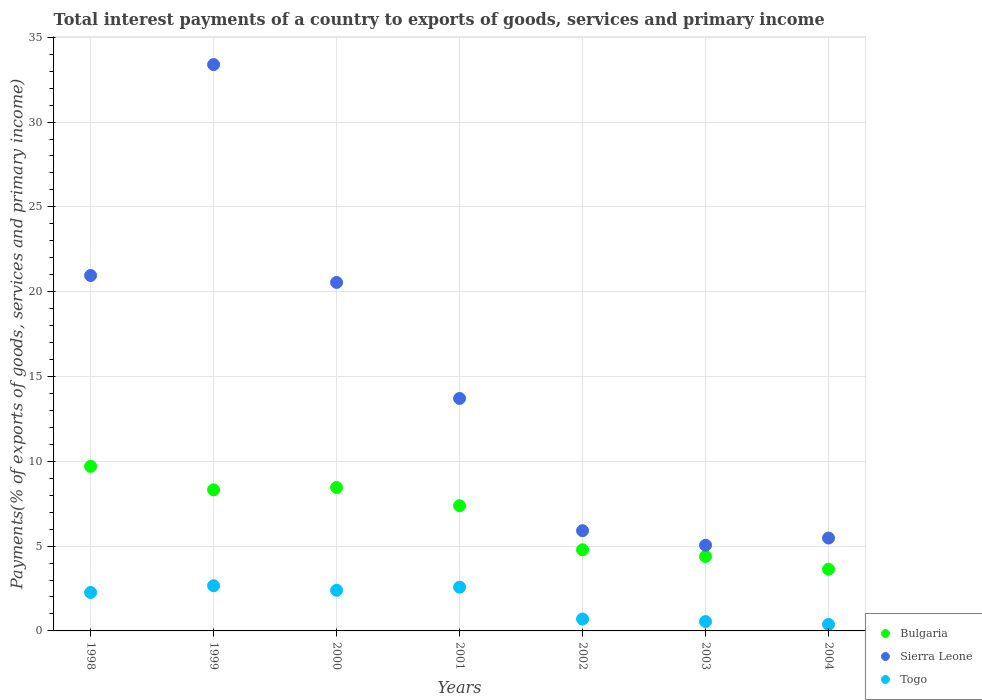What is the total interest payments in Sierra Leone in 2004?
Offer a terse response. 5.48. Across all years, what is the maximum total interest payments in Togo?
Provide a succinct answer. 2.66. Across all years, what is the minimum total interest payments in Sierra Leone?
Give a very brief answer. 5.05. In which year was the total interest payments in Sierra Leone maximum?
Provide a short and direct response. 1999. In which year was the total interest payments in Sierra Leone minimum?
Ensure brevity in your answer.  2003. What is the total total interest payments in Sierra Leone in the graph?
Your answer should be compact. 105.03. What is the difference between the total interest payments in Togo in 2003 and that in 2004?
Make the answer very short. 0.17. What is the difference between the total interest payments in Bulgaria in 2004 and the total interest payments in Togo in 2000?
Offer a terse response. 1.24. What is the average total interest payments in Bulgaria per year?
Ensure brevity in your answer.  6.67. In the year 1999, what is the difference between the total interest payments in Togo and total interest payments in Bulgaria?
Provide a succinct answer. -5.65. What is the ratio of the total interest payments in Togo in 1998 to that in 1999?
Keep it short and to the point. 0.85. Is the total interest payments in Sierra Leone in 2003 less than that in 2004?
Give a very brief answer. Yes. What is the difference between the highest and the second highest total interest payments in Togo?
Ensure brevity in your answer.  0.08. What is the difference between the highest and the lowest total interest payments in Bulgaria?
Your answer should be very brief. 6.07. In how many years, is the total interest payments in Togo greater than the average total interest payments in Togo taken over all years?
Keep it short and to the point. 4. Is the sum of the total interest payments in Togo in 2001 and 2002 greater than the maximum total interest payments in Bulgaria across all years?
Offer a very short reply. No. Does the total interest payments in Sierra Leone monotonically increase over the years?
Your response must be concise. No. Is the total interest payments in Sierra Leone strictly greater than the total interest payments in Bulgaria over the years?
Keep it short and to the point. Yes. How many years are there in the graph?
Provide a succinct answer. 7. What is the difference between two consecutive major ticks on the Y-axis?
Your response must be concise. 5. Are the values on the major ticks of Y-axis written in scientific E-notation?
Give a very brief answer. No. Does the graph contain grids?
Your answer should be compact. Yes. Where does the legend appear in the graph?
Make the answer very short. Bottom right. How are the legend labels stacked?
Ensure brevity in your answer.  Vertical. What is the title of the graph?
Offer a terse response. Total interest payments of a country to exports of goods, services and primary income. Does "Sudan" appear as one of the legend labels in the graph?
Your response must be concise. No. What is the label or title of the X-axis?
Provide a short and direct response. Years. What is the label or title of the Y-axis?
Give a very brief answer. Payments(% of exports of goods, services and primary income). What is the Payments(% of exports of goods, services and primary income) of Bulgaria in 1998?
Make the answer very short. 9.7. What is the Payments(% of exports of goods, services and primary income) of Sierra Leone in 1998?
Provide a short and direct response. 20.95. What is the Payments(% of exports of goods, services and primary income) of Togo in 1998?
Provide a short and direct response. 2.27. What is the Payments(% of exports of goods, services and primary income) in Bulgaria in 1999?
Keep it short and to the point. 8.32. What is the Payments(% of exports of goods, services and primary income) of Sierra Leone in 1999?
Provide a short and direct response. 33.39. What is the Payments(% of exports of goods, services and primary income) of Togo in 1999?
Offer a very short reply. 2.66. What is the Payments(% of exports of goods, services and primary income) in Bulgaria in 2000?
Provide a short and direct response. 8.45. What is the Payments(% of exports of goods, services and primary income) of Sierra Leone in 2000?
Your response must be concise. 20.55. What is the Payments(% of exports of goods, services and primary income) in Togo in 2000?
Offer a very short reply. 2.4. What is the Payments(% of exports of goods, services and primary income) of Bulgaria in 2001?
Your answer should be compact. 7.38. What is the Payments(% of exports of goods, services and primary income) of Sierra Leone in 2001?
Provide a short and direct response. 13.71. What is the Payments(% of exports of goods, services and primary income) of Togo in 2001?
Ensure brevity in your answer.  2.58. What is the Payments(% of exports of goods, services and primary income) of Bulgaria in 2002?
Your answer should be very brief. 4.78. What is the Payments(% of exports of goods, services and primary income) in Sierra Leone in 2002?
Your answer should be compact. 5.91. What is the Payments(% of exports of goods, services and primary income) of Togo in 2002?
Offer a very short reply. 0.7. What is the Payments(% of exports of goods, services and primary income) of Bulgaria in 2003?
Ensure brevity in your answer.  4.39. What is the Payments(% of exports of goods, services and primary income) in Sierra Leone in 2003?
Make the answer very short. 5.05. What is the Payments(% of exports of goods, services and primary income) in Togo in 2003?
Ensure brevity in your answer.  0.55. What is the Payments(% of exports of goods, services and primary income) in Bulgaria in 2004?
Keep it short and to the point. 3.64. What is the Payments(% of exports of goods, services and primary income) in Sierra Leone in 2004?
Make the answer very short. 5.48. What is the Payments(% of exports of goods, services and primary income) in Togo in 2004?
Your response must be concise. 0.38. Across all years, what is the maximum Payments(% of exports of goods, services and primary income) in Bulgaria?
Offer a terse response. 9.7. Across all years, what is the maximum Payments(% of exports of goods, services and primary income) in Sierra Leone?
Provide a short and direct response. 33.39. Across all years, what is the maximum Payments(% of exports of goods, services and primary income) in Togo?
Offer a terse response. 2.66. Across all years, what is the minimum Payments(% of exports of goods, services and primary income) of Bulgaria?
Your answer should be compact. 3.64. Across all years, what is the minimum Payments(% of exports of goods, services and primary income) of Sierra Leone?
Make the answer very short. 5.05. Across all years, what is the minimum Payments(% of exports of goods, services and primary income) in Togo?
Your answer should be very brief. 0.38. What is the total Payments(% of exports of goods, services and primary income) of Bulgaria in the graph?
Offer a terse response. 46.66. What is the total Payments(% of exports of goods, services and primary income) of Sierra Leone in the graph?
Your answer should be very brief. 105.03. What is the total Payments(% of exports of goods, services and primary income) in Togo in the graph?
Provide a succinct answer. 11.54. What is the difference between the Payments(% of exports of goods, services and primary income) of Bulgaria in 1998 and that in 1999?
Provide a short and direct response. 1.38. What is the difference between the Payments(% of exports of goods, services and primary income) of Sierra Leone in 1998 and that in 1999?
Give a very brief answer. -12.44. What is the difference between the Payments(% of exports of goods, services and primary income) in Togo in 1998 and that in 1999?
Offer a very short reply. -0.4. What is the difference between the Payments(% of exports of goods, services and primary income) of Bulgaria in 1998 and that in 2000?
Offer a terse response. 1.25. What is the difference between the Payments(% of exports of goods, services and primary income) of Sierra Leone in 1998 and that in 2000?
Ensure brevity in your answer.  0.41. What is the difference between the Payments(% of exports of goods, services and primary income) in Togo in 1998 and that in 2000?
Ensure brevity in your answer.  -0.13. What is the difference between the Payments(% of exports of goods, services and primary income) of Bulgaria in 1998 and that in 2001?
Your answer should be very brief. 2.32. What is the difference between the Payments(% of exports of goods, services and primary income) of Sierra Leone in 1998 and that in 2001?
Your answer should be compact. 7.25. What is the difference between the Payments(% of exports of goods, services and primary income) of Togo in 1998 and that in 2001?
Provide a short and direct response. -0.31. What is the difference between the Payments(% of exports of goods, services and primary income) of Bulgaria in 1998 and that in 2002?
Your answer should be very brief. 4.92. What is the difference between the Payments(% of exports of goods, services and primary income) in Sierra Leone in 1998 and that in 2002?
Give a very brief answer. 15.05. What is the difference between the Payments(% of exports of goods, services and primary income) in Togo in 1998 and that in 2002?
Your answer should be very brief. 1.56. What is the difference between the Payments(% of exports of goods, services and primary income) of Bulgaria in 1998 and that in 2003?
Provide a short and direct response. 5.31. What is the difference between the Payments(% of exports of goods, services and primary income) in Sierra Leone in 1998 and that in 2003?
Your response must be concise. 15.9. What is the difference between the Payments(% of exports of goods, services and primary income) in Togo in 1998 and that in 2003?
Your answer should be very brief. 1.71. What is the difference between the Payments(% of exports of goods, services and primary income) of Bulgaria in 1998 and that in 2004?
Make the answer very short. 6.07. What is the difference between the Payments(% of exports of goods, services and primary income) of Sierra Leone in 1998 and that in 2004?
Your answer should be very brief. 15.48. What is the difference between the Payments(% of exports of goods, services and primary income) in Togo in 1998 and that in 2004?
Offer a very short reply. 1.88. What is the difference between the Payments(% of exports of goods, services and primary income) in Bulgaria in 1999 and that in 2000?
Provide a succinct answer. -0.14. What is the difference between the Payments(% of exports of goods, services and primary income) in Sierra Leone in 1999 and that in 2000?
Provide a short and direct response. 12.84. What is the difference between the Payments(% of exports of goods, services and primary income) in Togo in 1999 and that in 2000?
Offer a terse response. 0.27. What is the difference between the Payments(% of exports of goods, services and primary income) of Bulgaria in 1999 and that in 2001?
Keep it short and to the point. 0.94. What is the difference between the Payments(% of exports of goods, services and primary income) in Sierra Leone in 1999 and that in 2001?
Ensure brevity in your answer.  19.68. What is the difference between the Payments(% of exports of goods, services and primary income) of Togo in 1999 and that in 2001?
Provide a short and direct response. 0.08. What is the difference between the Payments(% of exports of goods, services and primary income) of Bulgaria in 1999 and that in 2002?
Provide a short and direct response. 3.53. What is the difference between the Payments(% of exports of goods, services and primary income) in Sierra Leone in 1999 and that in 2002?
Provide a short and direct response. 27.48. What is the difference between the Payments(% of exports of goods, services and primary income) of Togo in 1999 and that in 2002?
Give a very brief answer. 1.96. What is the difference between the Payments(% of exports of goods, services and primary income) of Bulgaria in 1999 and that in 2003?
Make the answer very short. 3.93. What is the difference between the Payments(% of exports of goods, services and primary income) of Sierra Leone in 1999 and that in 2003?
Your answer should be compact. 28.34. What is the difference between the Payments(% of exports of goods, services and primary income) in Togo in 1999 and that in 2003?
Your response must be concise. 2.11. What is the difference between the Payments(% of exports of goods, services and primary income) in Bulgaria in 1999 and that in 2004?
Your response must be concise. 4.68. What is the difference between the Payments(% of exports of goods, services and primary income) of Sierra Leone in 1999 and that in 2004?
Your answer should be compact. 27.91. What is the difference between the Payments(% of exports of goods, services and primary income) of Togo in 1999 and that in 2004?
Provide a succinct answer. 2.28. What is the difference between the Payments(% of exports of goods, services and primary income) of Bulgaria in 2000 and that in 2001?
Keep it short and to the point. 1.07. What is the difference between the Payments(% of exports of goods, services and primary income) in Sierra Leone in 2000 and that in 2001?
Keep it short and to the point. 6.84. What is the difference between the Payments(% of exports of goods, services and primary income) of Togo in 2000 and that in 2001?
Offer a terse response. -0.18. What is the difference between the Payments(% of exports of goods, services and primary income) in Bulgaria in 2000 and that in 2002?
Ensure brevity in your answer.  3.67. What is the difference between the Payments(% of exports of goods, services and primary income) in Sierra Leone in 2000 and that in 2002?
Your answer should be compact. 14.64. What is the difference between the Payments(% of exports of goods, services and primary income) of Togo in 2000 and that in 2002?
Your response must be concise. 1.7. What is the difference between the Payments(% of exports of goods, services and primary income) of Bulgaria in 2000 and that in 2003?
Your answer should be very brief. 4.07. What is the difference between the Payments(% of exports of goods, services and primary income) in Sierra Leone in 2000 and that in 2003?
Keep it short and to the point. 15.49. What is the difference between the Payments(% of exports of goods, services and primary income) of Togo in 2000 and that in 2003?
Keep it short and to the point. 1.85. What is the difference between the Payments(% of exports of goods, services and primary income) of Bulgaria in 2000 and that in 2004?
Offer a terse response. 4.82. What is the difference between the Payments(% of exports of goods, services and primary income) of Sierra Leone in 2000 and that in 2004?
Make the answer very short. 15.07. What is the difference between the Payments(% of exports of goods, services and primary income) of Togo in 2000 and that in 2004?
Make the answer very short. 2.01. What is the difference between the Payments(% of exports of goods, services and primary income) in Bulgaria in 2001 and that in 2002?
Provide a short and direct response. 2.6. What is the difference between the Payments(% of exports of goods, services and primary income) in Sierra Leone in 2001 and that in 2002?
Your answer should be compact. 7.8. What is the difference between the Payments(% of exports of goods, services and primary income) in Togo in 2001 and that in 2002?
Offer a terse response. 1.88. What is the difference between the Payments(% of exports of goods, services and primary income) of Bulgaria in 2001 and that in 2003?
Ensure brevity in your answer.  2.99. What is the difference between the Payments(% of exports of goods, services and primary income) of Sierra Leone in 2001 and that in 2003?
Provide a short and direct response. 8.65. What is the difference between the Payments(% of exports of goods, services and primary income) in Togo in 2001 and that in 2003?
Your response must be concise. 2.03. What is the difference between the Payments(% of exports of goods, services and primary income) of Bulgaria in 2001 and that in 2004?
Provide a succinct answer. 3.74. What is the difference between the Payments(% of exports of goods, services and primary income) in Sierra Leone in 2001 and that in 2004?
Your answer should be compact. 8.23. What is the difference between the Payments(% of exports of goods, services and primary income) in Togo in 2001 and that in 2004?
Your answer should be compact. 2.19. What is the difference between the Payments(% of exports of goods, services and primary income) of Bulgaria in 2002 and that in 2003?
Make the answer very short. 0.39. What is the difference between the Payments(% of exports of goods, services and primary income) in Sierra Leone in 2002 and that in 2003?
Give a very brief answer. 0.86. What is the difference between the Payments(% of exports of goods, services and primary income) of Togo in 2002 and that in 2003?
Give a very brief answer. 0.15. What is the difference between the Payments(% of exports of goods, services and primary income) of Bulgaria in 2002 and that in 2004?
Provide a short and direct response. 1.15. What is the difference between the Payments(% of exports of goods, services and primary income) in Sierra Leone in 2002 and that in 2004?
Your answer should be compact. 0.43. What is the difference between the Payments(% of exports of goods, services and primary income) of Togo in 2002 and that in 2004?
Give a very brief answer. 0.32. What is the difference between the Payments(% of exports of goods, services and primary income) in Bulgaria in 2003 and that in 2004?
Your response must be concise. 0.75. What is the difference between the Payments(% of exports of goods, services and primary income) of Sierra Leone in 2003 and that in 2004?
Your response must be concise. -0.42. What is the difference between the Payments(% of exports of goods, services and primary income) in Togo in 2003 and that in 2004?
Provide a short and direct response. 0.17. What is the difference between the Payments(% of exports of goods, services and primary income) of Bulgaria in 1998 and the Payments(% of exports of goods, services and primary income) of Sierra Leone in 1999?
Your answer should be compact. -23.69. What is the difference between the Payments(% of exports of goods, services and primary income) of Bulgaria in 1998 and the Payments(% of exports of goods, services and primary income) of Togo in 1999?
Offer a terse response. 7.04. What is the difference between the Payments(% of exports of goods, services and primary income) in Sierra Leone in 1998 and the Payments(% of exports of goods, services and primary income) in Togo in 1999?
Your response must be concise. 18.29. What is the difference between the Payments(% of exports of goods, services and primary income) in Bulgaria in 1998 and the Payments(% of exports of goods, services and primary income) in Sierra Leone in 2000?
Offer a terse response. -10.84. What is the difference between the Payments(% of exports of goods, services and primary income) of Bulgaria in 1998 and the Payments(% of exports of goods, services and primary income) of Togo in 2000?
Your response must be concise. 7.31. What is the difference between the Payments(% of exports of goods, services and primary income) of Sierra Leone in 1998 and the Payments(% of exports of goods, services and primary income) of Togo in 2000?
Your response must be concise. 18.56. What is the difference between the Payments(% of exports of goods, services and primary income) in Bulgaria in 1998 and the Payments(% of exports of goods, services and primary income) in Sierra Leone in 2001?
Keep it short and to the point. -4. What is the difference between the Payments(% of exports of goods, services and primary income) in Bulgaria in 1998 and the Payments(% of exports of goods, services and primary income) in Togo in 2001?
Your answer should be compact. 7.12. What is the difference between the Payments(% of exports of goods, services and primary income) of Sierra Leone in 1998 and the Payments(% of exports of goods, services and primary income) of Togo in 2001?
Your answer should be very brief. 18.37. What is the difference between the Payments(% of exports of goods, services and primary income) in Bulgaria in 1998 and the Payments(% of exports of goods, services and primary income) in Sierra Leone in 2002?
Ensure brevity in your answer.  3.79. What is the difference between the Payments(% of exports of goods, services and primary income) in Bulgaria in 1998 and the Payments(% of exports of goods, services and primary income) in Togo in 2002?
Your response must be concise. 9. What is the difference between the Payments(% of exports of goods, services and primary income) in Sierra Leone in 1998 and the Payments(% of exports of goods, services and primary income) in Togo in 2002?
Offer a terse response. 20.25. What is the difference between the Payments(% of exports of goods, services and primary income) of Bulgaria in 1998 and the Payments(% of exports of goods, services and primary income) of Sierra Leone in 2003?
Ensure brevity in your answer.  4.65. What is the difference between the Payments(% of exports of goods, services and primary income) in Bulgaria in 1998 and the Payments(% of exports of goods, services and primary income) in Togo in 2003?
Provide a short and direct response. 9.15. What is the difference between the Payments(% of exports of goods, services and primary income) in Sierra Leone in 1998 and the Payments(% of exports of goods, services and primary income) in Togo in 2003?
Provide a succinct answer. 20.4. What is the difference between the Payments(% of exports of goods, services and primary income) in Bulgaria in 1998 and the Payments(% of exports of goods, services and primary income) in Sierra Leone in 2004?
Make the answer very short. 4.23. What is the difference between the Payments(% of exports of goods, services and primary income) in Bulgaria in 1998 and the Payments(% of exports of goods, services and primary income) in Togo in 2004?
Keep it short and to the point. 9.32. What is the difference between the Payments(% of exports of goods, services and primary income) in Sierra Leone in 1998 and the Payments(% of exports of goods, services and primary income) in Togo in 2004?
Your answer should be compact. 20.57. What is the difference between the Payments(% of exports of goods, services and primary income) of Bulgaria in 1999 and the Payments(% of exports of goods, services and primary income) of Sierra Leone in 2000?
Offer a very short reply. -12.23. What is the difference between the Payments(% of exports of goods, services and primary income) in Bulgaria in 1999 and the Payments(% of exports of goods, services and primary income) in Togo in 2000?
Ensure brevity in your answer.  5.92. What is the difference between the Payments(% of exports of goods, services and primary income) of Sierra Leone in 1999 and the Payments(% of exports of goods, services and primary income) of Togo in 2000?
Keep it short and to the point. 30.99. What is the difference between the Payments(% of exports of goods, services and primary income) in Bulgaria in 1999 and the Payments(% of exports of goods, services and primary income) in Sierra Leone in 2001?
Keep it short and to the point. -5.39. What is the difference between the Payments(% of exports of goods, services and primary income) in Bulgaria in 1999 and the Payments(% of exports of goods, services and primary income) in Togo in 2001?
Offer a terse response. 5.74. What is the difference between the Payments(% of exports of goods, services and primary income) in Sierra Leone in 1999 and the Payments(% of exports of goods, services and primary income) in Togo in 2001?
Provide a short and direct response. 30.81. What is the difference between the Payments(% of exports of goods, services and primary income) in Bulgaria in 1999 and the Payments(% of exports of goods, services and primary income) in Sierra Leone in 2002?
Your answer should be compact. 2.41. What is the difference between the Payments(% of exports of goods, services and primary income) of Bulgaria in 1999 and the Payments(% of exports of goods, services and primary income) of Togo in 2002?
Your answer should be compact. 7.62. What is the difference between the Payments(% of exports of goods, services and primary income) of Sierra Leone in 1999 and the Payments(% of exports of goods, services and primary income) of Togo in 2002?
Offer a terse response. 32.69. What is the difference between the Payments(% of exports of goods, services and primary income) of Bulgaria in 1999 and the Payments(% of exports of goods, services and primary income) of Sierra Leone in 2003?
Ensure brevity in your answer.  3.26. What is the difference between the Payments(% of exports of goods, services and primary income) in Bulgaria in 1999 and the Payments(% of exports of goods, services and primary income) in Togo in 2003?
Your answer should be compact. 7.77. What is the difference between the Payments(% of exports of goods, services and primary income) in Sierra Leone in 1999 and the Payments(% of exports of goods, services and primary income) in Togo in 2003?
Your answer should be compact. 32.84. What is the difference between the Payments(% of exports of goods, services and primary income) of Bulgaria in 1999 and the Payments(% of exports of goods, services and primary income) of Sierra Leone in 2004?
Your answer should be compact. 2.84. What is the difference between the Payments(% of exports of goods, services and primary income) in Bulgaria in 1999 and the Payments(% of exports of goods, services and primary income) in Togo in 2004?
Your answer should be very brief. 7.93. What is the difference between the Payments(% of exports of goods, services and primary income) in Sierra Leone in 1999 and the Payments(% of exports of goods, services and primary income) in Togo in 2004?
Your response must be concise. 33. What is the difference between the Payments(% of exports of goods, services and primary income) in Bulgaria in 2000 and the Payments(% of exports of goods, services and primary income) in Sierra Leone in 2001?
Keep it short and to the point. -5.25. What is the difference between the Payments(% of exports of goods, services and primary income) in Bulgaria in 2000 and the Payments(% of exports of goods, services and primary income) in Togo in 2001?
Your answer should be compact. 5.88. What is the difference between the Payments(% of exports of goods, services and primary income) of Sierra Leone in 2000 and the Payments(% of exports of goods, services and primary income) of Togo in 2001?
Give a very brief answer. 17.97. What is the difference between the Payments(% of exports of goods, services and primary income) of Bulgaria in 2000 and the Payments(% of exports of goods, services and primary income) of Sierra Leone in 2002?
Your answer should be compact. 2.55. What is the difference between the Payments(% of exports of goods, services and primary income) of Bulgaria in 2000 and the Payments(% of exports of goods, services and primary income) of Togo in 2002?
Provide a short and direct response. 7.75. What is the difference between the Payments(% of exports of goods, services and primary income) in Sierra Leone in 2000 and the Payments(% of exports of goods, services and primary income) in Togo in 2002?
Keep it short and to the point. 19.84. What is the difference between the Payments(% of exports of goods, services and primary income) of Bulgaria in 2000 and the Payments(% of exports of goods, services and primary income) of Sierra Leone in 2003?
Provide a short and direct response. 3.4. What is the difference between the Payments(% of exports of goods, services and primary income) in Bulgaria in 2000 and the Payments(% of exports of goods, services and primary income) in Togo in 2003?
Make the answer very short. 7.9. What is the difference between the Payments(% of exports of goods, services and primary income) in Sierra Leone in 2000 and the Payments(% of exports of goods, services and primary income) in Togo in 2003?
Provide a succinct answer. 20. What is the difference between the Payments(% of exports of goods, services and primary income) of Bulgaria in 2000 and the Payments(% of exports of goods, services and primary income) of Sierra Leone in 2004?
Your response must be concise. 2.98. What is the difference between the Payments(% of exports of goods, services and primary income) of Bulgaria in 2000 and the Payments(% of exports of goods, services and primary income) of Togo in 2004?
Provide a short and direct response. 8.07. What is the difference between the Payments(% of exports of goods, services and primary income) of Sierra Leone in 2000 and the Payments(% of exports of goods, services and primary income) of Togo in 2004?
Offer a very short reply. 20.16. What is the difference between the Payments(% of exports of goods, services and primary income) of Bulgaria in 2001 and the Payments(% of exports of goods, services and primary income) of Sierra Leone in 2002?
Make the answer very short. 1.47. What is the difference between the Payments(% of exports of goods, services and primary income) of Bulgaria in 2001 and the Payments(% of exports of goods, services and primary income) of Togo in 2002?
Provide a succinct answer. 6.68. What is the difference between the Payments(% of exports of goods, services and primary income) of Sierra Leone in 2001 and the Payments(% of exports of goods, services and primary income) of Togo in 2002?
Ensure brevity in your answer.  13. What is the difference between the Payments(% of exports of goods, services and primary income) of Bulgaria in 2001 and the Payments(% of exports of goods, services and primary income) of Sierra Leone in 2003?
Offer a terse response. 2.33. What is the difference between the Payments(% of exports of goods, services and primary income) in Bulgaria in 2001 and the Payments(% of exports of goods, services and primary income) in Togo in 2003?
Offer a terse response. 6.83. What is the difference between the Payments(% of exports of goods, services and primary income) in Sierra Leone in 2001 and the Payments(% of exports of goods, services and primary income) in Togo in 2003?
Keep it short and to the point. 13.15. What is the difference between the Payments(% of exports of goods, services and primary income) of Bulgaria in 2001 and the Payments(% of exports of goods, services and primary income) of Sierra Leone in 2004?
Offer a very short reply. 1.9. What is the difference between the Payments(% of exports of goods, services and primary income) of Bulgaria in 2001 and the Payments(% of exports of goods, services and primary income) of Togo in 2004?
Make the answer very short. 7. What is the difference between the Payments(% of exports of goods, services and primary income) of Sierra Leone in 2001 and the Payments(% of exports of goods, services and primary income) of Togo in 2004?
Ensure brevity in your answer.  13.32. What is the difference between the Payments(% of exports of goods, services and primary income) in Bulgaria in 2002 and the Payments(% of exports of goods, services and primary income) in Sierra Leone in 2003?
Your answer should be very brief. -0.27. What is the difference between the Payments(% of exports of goods, services and primary income) of Bulgaria in 2002 and the Payments(% of exports of goods, services and primary income) of Togo in 2003?
Your answer should be very brief. 4.23. What is the difference between the Payments(% of exports of goods, services and primary income) of Sierra Leone in 2002 and the Payments(% of exports of goods, services and primary income) of Togo in 2003?
Your answer should be compact. 5.36. What is the difference between the Payments(% of exports of goods, services and primary income) of Bulgaria in 2002 and the Payments(% of exports of goods, services and primary income) of Sierra Leone in 2004?
Offer a very short reply. -0.69. What is the difference between the Payments(% of exports of goods, services and primary income) of Bulgaria in 2002 and the Payments(% of exports of goods, services and primary income) of Togo in 2004?
Keep it short and to the point. 4.4. What is the difference between the Payments(% of exports of goods, services and primary income) of Sierra Leone in 2002 and the Payments(% of exports of goods, services and primary income) of Togo in 2004?
Give a very brief answer. 5.52. What is the difference between the Payments(% of exports of goods, services and primary income) of Bulgaria in 2003 and the Payments(% of exports of goods, services and primary income) of Sierra Leone in 2004?
Give a very brief answer. -1.09. What is the difference between the Payments(% of exports of goods, services and primary income) in Bulgaria in 2003 and the Payments(% of exports of goods, services and primary income) in Togo in 2004?
Offer a terse response. 4. What is the difference between the Payments(% of exports of goods, services and primary income) in Sierra Leone in 2003 and the Payments(% of exports of goods, services and primary income) in Togo in 2004?
Give a very brief answer. 4.67. What is the average Payments(% of exports of goods, services and primary income) in Bulgaria per year?
Give a very brief answer. 6.67. What is the average Payments(% of exports of goods, services and primary income) in Sierra Leone per year?
Offer a terse response. 15. What is the average Payments(% of exports of goods, services and primary income) of Togo per year?
Give a very brief answer. 1.65. In the year 1998, what is the difference between the Payments(% of exports of goods, services and primary income) in Bulgaria and Payments(% of exports of goods, services and primary income) in Sierra Leone?
Your response must be concise. -11.25. In the year 1998, what is the difference between the Payments(% of exports of goods, services and primary income) of Bulgaria and Payments(% of exports of goods, services and primary income) of Togo?
Make the answer very short. 7.44. In the year 1998, what is the difference between the Payments(% of exports of goods, services and primary income) of Sierra Leone and Payments(% of exports of goods, services and primary income) of Togo?
Keep it short and to the point. 18.69. In the year 1999, what is the difference between the Payments(% of exports of goods, services and primary income) of Bulgaria and Payments(% of exports of goods, services and primary income) of Sierra Leone?
Your answer should be very brief. -25.07. In the year 1999, what is the difference between the Payments(% of exports of goods, services and primary income) in Bulgaria and Payments(% of exports of goods, services and primary income) in Togo?
Provide a succinct answer. 5.65. In the year 1999, what is the difference between the Payments(% of exports of goods, services and primary income) of Sierra Leone and Payments(% of exports of goods, services and primary income) of Togo?
Your answer should be compact. 30.73. In the year 2000, what is the difference between the Payments(% of exports of goods, services and primary income) in Bulgaria and Payments(% of exports of goods, services and primary income) in Sierra Leone?
Provide a short and direct response. -12.09. In the year 2000, what is the difference between the Payments(% of exports of goods, services and primary income) of Bulgaria and Payments(% of exports of goods, services and primary income) of Togo?
Provide a short and direct response. 6.06. In the year 2000, what is the difference between the Payments(% of exports of goods, services and primary income) in Sierra Leone and Payments(% of exports of goods, services and primary income) in Togo?
Offer a very short reply. 18.15. In the year 2001, what is the difference between the Payments(% of exports of goods, services and primary income) in Bulgaria and Payments(% of exports of goods, services and primary income) in Sierra Leone?
Offer a terse response. -6.33. In the year 2001, what is the difference between the Payments(% of exports of goods, services and primary income) in Bulgaria and Payments(% of exports of goods, services and primary income) in Togo?
Make the answer very short. 4.8. In the year 2001, what is the difference between the Payments(% of exports of goods, services and primary income) in Sierra Leone and Payments(% of exports of goods, services and primary income) in Togo?
Provide a short and direct response. 11.13. In the year 2002, what is the difference between the Payments(% of exports of goods, services and primary income) of Bulgaria and Payments(% of exports of goods, services and primary income) of Sierra Leone?
Your response must be concise. -1.13. In the year 2002, what is the difference between the Payments(% of exports of goods, services and primary income) in Bulgaria and Payments(% of exports of goods, services and primary income) in Togo?
Make the answer very short. 4.08. In the year 2002, what is the difference between the Payments(% of exports of goods, services and primary income) of Sierra Leone and Payments(% of exports of goods, services and primary income) of Togo?
Offer a terse response. 5.21. In the year 2003, what is the difference between the Payments(% of exports of goods, services and primary income) in Bulgaria and Payments(% of exports of goods, services and primary income) in Sierra Leone?
Ensure brevity in your answer.  -0.66. In the year 2003, what is the difference between the Payments(% of exports of goods, services and primary income) in Bulgaria and Payments(% of exports of goods, services and primary income) in Togo?
Keep it short and to the point. 3.84. In the year 2003, what is the difference between the Payments(% of exports of goods, services and primary income) of Sierra Leone and Payments(% of exports of goods, services and primary income) of Togo?
Offer a very short reply. 4.5. In the year 2004, what is the difference between the Payments(% of exports of goods, services and primary income) in Bulgaria and Payments(% of exports of goods, services and primary income) in Sierra Leone?
Offer a terse response. -1.84. In the year 2004, what is the difference between the Payments(% of exports of goods, services and primary income) in Bulgaria and Payments(% of exports of goods, services and primary income) in Togo?
Your answer should be very brief. 3.25. In the year 2004, what is the difference between the Payments(% of exports of goods, services and primary income) in Sierra Leone and Payments(% of exports of goods, services and primary income) in Togo?
Provide a succinct answer. 5.09. What is the ratio of the Payments(% of exports of goods, services and primary income) in Bulgaria in 1998 to that in 1999?
Offer a terse response. 1.17. What is the ratio of the Payments(% of exports of goods, services and primary income) in Sierra Leone in 1998 to that in 1999?
Offer a terse response. 0.63. What is the ratio of the Payments(% of exports of goods, services and primary income) of Togo in 1998 to that in 1999?
Your answer should be very brief. 0.85. What is the ratio of the Payments(% of exports of goods, services and primary income) in Bulgaria in 1998 to that in 2000?
Give a very brief answer. 1.15. What is the ratio of the Payments(% of exports of goods, services and primary income) in Sierra Leone in 1998 to that in 2000?
Give a very brief answer. 1.02. What is the ratio of the Payments(% of exports of goods, services and primary income) of Togo in 1998 to that in 2000?
Your answer should be very brief. 0.95. What is the ratio of the Payments(% of exports of goods, services and primary income) of Bulgaria in 1998 to that in 2001?
Keep it short and to the point. 1.31. What is the ratio of the Payments(% of exports of goods, services and primary income) of Sierra Leone in 1998 to that in 2001?
Keep it short and to the point. 1.53. What is the ratio of the Payments(% of exports of goods, services and primary income) of Togo in 1998 to that in 2001?
Offer a terse response. 0.88. What is the ratio of the Payments(% of exports of goods, services and primary income) in Bulgaria in 1998 to that in 2002?
Give a very brief answer. 2.03. What is the ratio of the Payments(% of exports of goods, services and primary income) in Sierra Leone in 1998 to that in 2002?
Provide a succinct answer. 3.55. What is the ratio of the Payments(% of exports of goods, services and primary income) in Togo in 1998 to that in 2002?
Your response must be concise. 3.23. What is the ratio of the Payments(% of exports of goods, services and primary income) of Bulgaria in 1998 to that in 2003?
Your response must be concise. 2.21. What is the ratio of the Payments(% of exports of goods, services and primary income) of Sierra Leone in 1998 to that in 2003?
Give a very brief answer. 4.15. What is the ratio of the Payments(% of exports of goods, services and primary income) in Togo in 1998 to that in 2003?
Provide a short and direct response. 4.12. What is the ratio of the Payments(% of exports of goods, services and primary income) in Bulgaria in 1998 to that in 2004?
Make the answer very short. 2.67. What is the ratio of the Payments(% of exports of goods, services and primary income) of Sierra Leone in 1998 to that in 2004?
Ensure brevity in your answer.  3.83. What is the ratio of the Payments(% of exports of goods, services and primary income) of Togo in 1998 to that in 2004?
Your answer should be compact. 5.89. What is the ratio of the Payments(% of exports of goods, services and primary income) in Bulgaria in 1999 to that in 2000?
Your answer should be very brief. 0.98. What is the ratio of the Payments(% of exports of goods, services and primary income) of Sierra Leone in 1999 to that in 2000?
Ensure brevity in your answer.  1.63. What is the ratio of the Payments(% of exports of goods, services and primary income) in Togo in 1999 to that in 2000?
Your answer should be very brief. 1.11. What is the ratio of the Payments(% of exports of goods, services and primary income) in Bulgaria in 1999 to that in 2001?
Offer a very short reply. 1.13. What is the ratio of the Payments(% of exports of goods, services and primary income) in Sierra Leone in 1999 to that in 2001?
Your response must be concise. 2.44. What is the ratio of the Payments(% of exports of goods, services and primary income) of Togo in 1999 to that in 2001?
Provide a succinct answer. 1.03. What is the ratio of the Payments(% of exports of goods, services and primary income) of Bulgaria in 1999 to that in 2002?
Make the answer very short. 1.74. What is the ratio of the Payments(% of exports of goods, services and primary income) of Sierra Leone in 1999 to that in 2002?
Offer a very short reply. 5.65. What is the ratio of the Payments(% of exports of goods, services and primary income) in Togo in 1999 to that in 2002?
Provide a short and direct response. 3.8. What is the ratio of the Payments(% of exports of goods, services and primary income) of Bulgaria in 1999 to that in 2003?
Your answer should be compact. 1.9. What is the ratio of the Payments(% of exports of goods, services and primary income) of Sierra Leone in 1999 to that in 2003?
Keep it short and to the point. 6.61. What is the ratio of the Payments(% of exports of goods, services and primary income) of Togo in 1999 to that in 2003?
Your answer should be compact. 4.84. What is the ratio of the Payments(% of exports of goods, services and primary income) in Bulgaria in 1999 to that in 2004?
Your answer should be very brief. 2.29. What is the ratio of the Payments(% of exports of goods, services and primary income) in Sierra Leone in 1999 to that in 2004?
Make the answer very short. 6.1. What is the ratio of the Payments(% of exports of goods, services and primary income) in Togo in 1999 to that in 2004?
Offer a terse response. 6.93. What is the ratio of the Payments(% of exports of goods, services and primary income) of Bulgaria in 2000 to that in 2001?
Ensure brevity in your answer.  1.15. What is the ratio of the Payments(% of exports of goods, services and primary income) of Sierra Leone in 2000 to that in 2001?
Keep it short and to the point. 1.5. What is the ratio of the Payments(% of exports of goods, services and primary income) of Togo in 2000 to that in 2001?
Keep it short and to the point. 0.93. What is the ratio of the Payments(% of exports of goods, services and primary income) of Bulgaria in 2000 to that in 2002?
Your answer should be compact. 1.77. What is the ratio of the Payments(% of exports of goods, services and primary income) in Sierra Leone in 2000 to that in 2002?
Your response must be concise. 3.48. What is the ratio of the Payments(% of exports of goods, services and primary income) in Togo in 2000 to that in 2002?
Your answer should be very brief. 3.42. What is the ratio of the Payments(% of exports of goods, services and primary income) in Bulgaria in 2000 to that in 2003?
Make the answer very short. 1.93. What is the ratio of the Payments(% of exports of goods, services and primary income) of Sierra Leone in 2000 to that in 2003?
Ensure brevity in your answer.  4.07. What is the ratio of the Payments(% of exports of goods, services and primary income) in Togo in 2000 to that in 2003?
Offer a terse response. 4.35. What is the ratio of the Payments(% of exports of goods, services and primary income) in Bulgaria in 2000 to that in 2004?
Offer a very short reply. 2.33. What is the ratio of the Payments(% of exports of goods, services and primary income) of Sierra Leone in 2000 to that in 2004?
Offer a terse response. 3.75. What is the ratio of the Payments(% of exports of goods, services and primary income) of Togo in 2000 to that in 2004?
Your answer should be very brief. 6.23. What is the ratio of the Payments(% of exports of goods, services and primary income) of Bulgaria in 2001 to that in 2002?
Your response must be concise. 1.54. What is the ratio of the Payments(% of exports of goods, services and primary income) in Sierra Leone in 2001 to that in 2002?
Provide a short and direct response. 2.32. What is the ratio of the Payments(% of exports of goods, services and primary income) of Togo in 2001 to that in 2002?
Ensure brevity in your answer.  3.68. What is the ratio of the Payments(% of exports of goods, services and primary income) in Bulgaria in 2001 to that in 2003?
Your response must be concise. 1.68. What is the ratio of the Payments(% of exports of goods, services and primary income) of Sierra Leone in 2001 to that in 2003?
Provide a succinct answer. 2.71. What is the ratio of the Payments(% of exports of goods, services and primary income) in Togo in 2001 to that in 2003?
Your answer should be compact. 4.69. What is the ratio of the Payments(% of exports of goods, services and primary income) in Bulgaria in 2001 to that in 2004?
Ensure brevity in your answer.  2.03. What is the ratio of the Payments(% of exports of goods, services and primary income) in Sierra Leone in 2001 to that in 2004?
Your answer should be very brief. 2.5. What is the ratio of the Payments(% of exports of goods, services and primary income) in Togo in 2001 to that in 2004?
Ensure brevity in your answer.  6.71. What is the ratio of the Payments(% of exports of goods, services and primary income) of Bulgaria in 2002 to that in 2003?
Offer a very short reply. 1.09. What is the ratio of the Payments(% of exports of goods, services and primary income) in Sierra Leone in 2002 to that in 2003?
Provide a succinct answer. 1.17. What is the ratio of the Payments(% of exports of goods, services and primary income) in Togo in 2002 to that in 2003?
Give a very brief answer. 1.27. What is the ratio of the Payments(% of exports of goods, services and primary income) of Bulgaria in 2002 to that in 2004?
Make the answer very short. 1.32. What is the ratio of the Payments(% of exports of goods, services and primary income) in Sierra Leone in 2002 to that in 2004?
Offer a very short reply. 1.08. What is the ratio of the Payments(% of exports of goods, services and primary income) in Togo in 2002 to that in 2004?
Your answer should be compact. 1.82. What is the ratio of the Payments(% of exports of goods, services and primary income) in Bulgaria in 2003 to that in 2004?
Your answer should be compact. 1.21. What is the ratio of the Payments(% of exports of goods, services and primary income) of Sierra Leone in 2003 to that in 2004?
Keep it short and to the point. 0.92. What is the ratio of the Payments(% of exports of goods, services and primary income) of Togo in 2003 to that in 2004?
Offer a terse response. 1.43. What is the difference between the highest and the second highest Payments(% of exports of goods, services and primary income) of Bulgaria?
Give a very brief answer. 1.25. What is the difference between the highest and the second highest Payments(% of exports of goods, services and primary income) of Sierra Leone?
Keep it short and to the point. 12.44. What is the difference between the highest and the second highest Payments(% of exports of goods, services and primary income) in Togo?
Make the answer very short. 0.08. What is the difference between the highest and the lowest Payments(% of exports of goods, services and primary income) of Bulgaria?
Provide a succinct answer. 6.07. What is the difference between the highest and the lowest Payments(% of exports of goods, services and primary income) of Sierra Leone?
Provide a succinct answer. 28.34. What is the difference between the highest and the lowest Payments(% of exports of goods, services and primary income) of Togo?
Ensure brevity in your answer.  2.28. 